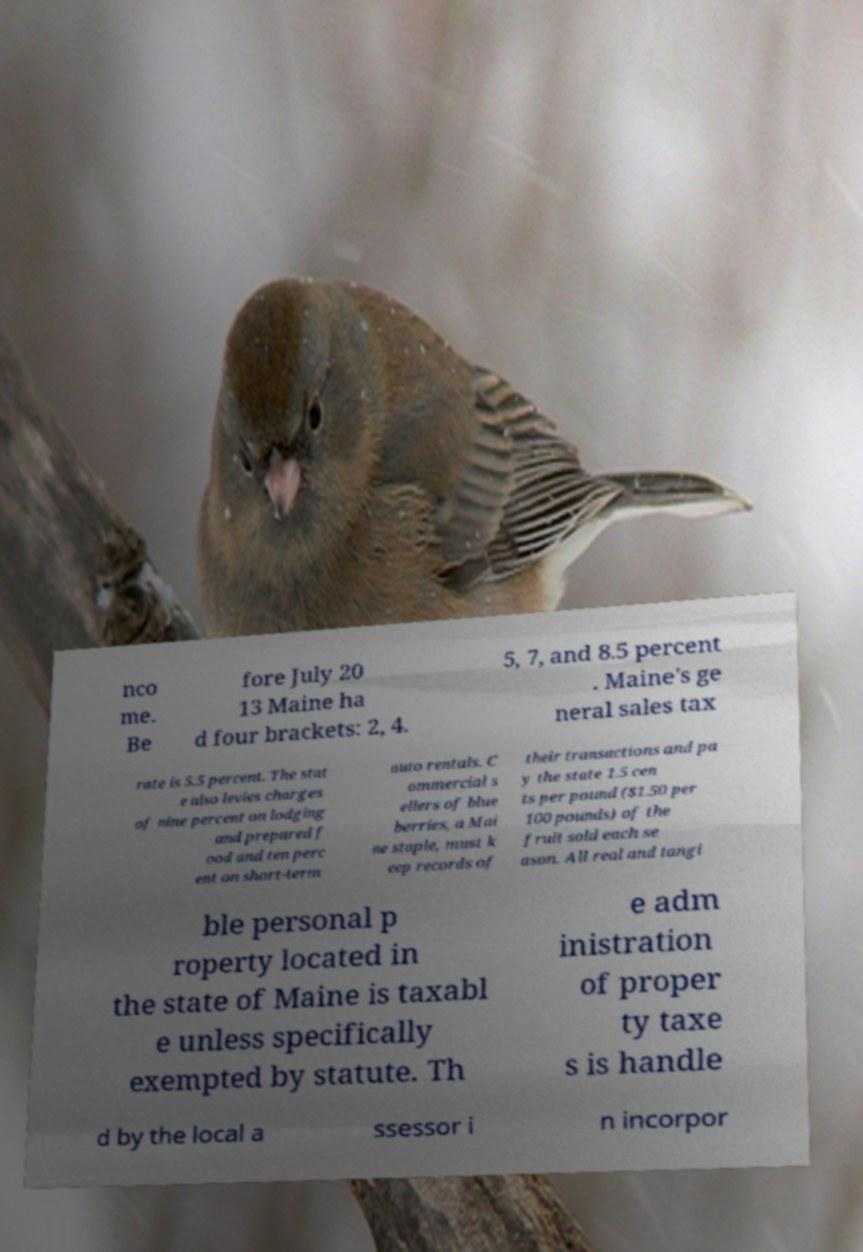Could you assist in decoding the text presented in this image and type it out clearly? nco me. Be fore July 20 13 Maine ha d four brackets: 2, 4. 5, 7, and 8.5 percent . Maine's ge neral sales tax rate is 5.5 percent. The stat e also levies charges of nine percent on lodging and prepared f ood and ten perc ent on short-term auto rentals. C ommercial s ellers of blue berries, a Mai ne staple, must k eep records of their transactions and pa y the state 1.5 cen ts per pound ($1.50 per 100 pounds) of the fruit sold each se ason. All real and tangi ble personal p roperty located in the state of Maine is taxabl e unless specifically exempted by statute. Th e adm inistration of proper ty taxe s is handle d by the local a ssessor i n incorpor 